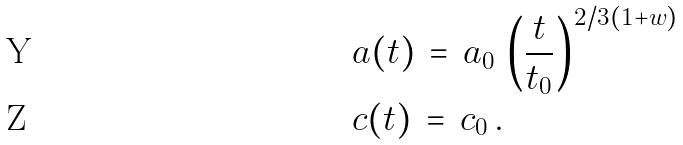<formula> <loc_0><loc_0><loc_500><loc_500>& a ( t ) \, = \, a _ { 0 } \, \left ( \frac { t } { t _ { 0 } } \right ) ^ { 2 / 3 ( 1 + w ) } \\ & c ( t ) \, = \, c _ { 0 } \, .</formula> 